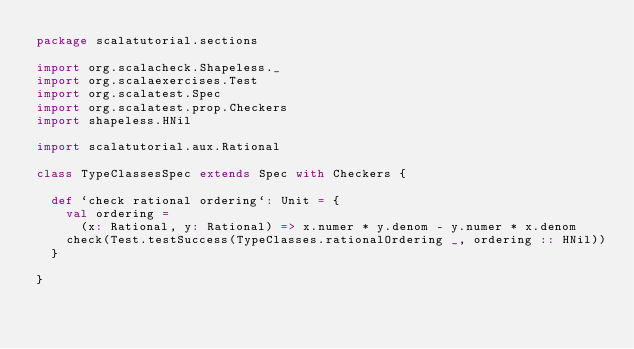Convert code to text. <code><loc_0><loc_0><loc_500><loc_500><_Scala_>package scalatutorial.sections

import org.scalacheck.Shapeless._
import org.scalaexercises.Test
import org.scalatest.Spec
import org.scalatest.prop.Checkers
import shapeless.HNil

import scalatutorial.aux.Rational

class TypeClassesSpec extends Spec with Checkers {

  def `check rational ordering`: Unit = {
    val ordering =
      (x: Rational, y: Rational) => x.numer * y.denom - y.numer * x.denom
    check(Test.testSuccess(TypeClasses.rationalOrdering _, ordering :: HNil))
  }

}
</code> 